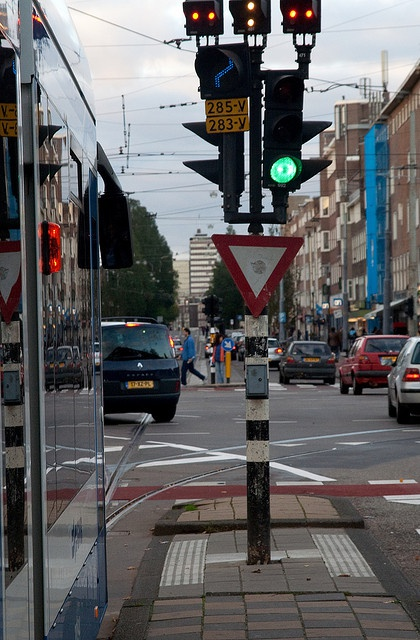Describe the objects in this image and their specific colors. I can see traffic light in lightgray, black, maroon, and gray tones, car in lightgray, black, darkblue, blue, and gray tones, car in lightgray, black, maroon, gray, and darkblue tones, car in lightgray, black, gray, darkgray, and maroon tones, and car in lightgray, black, gray, and darkblue tones in this image. 